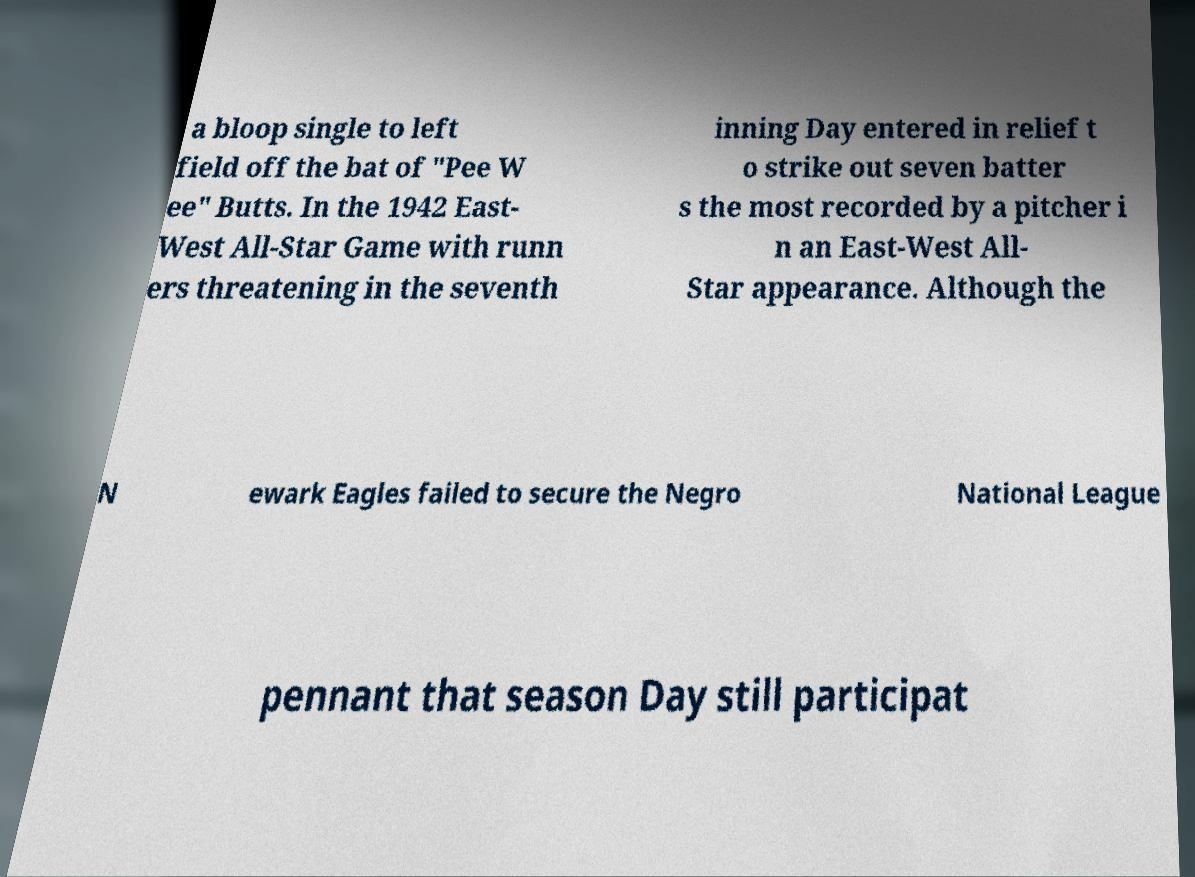Please read and relay the text visible in this image. What does it say? a bloop single to left field off the bat of "Pee W ee" Butts. In the 1942 East- West All-Star Game with runn ers threatening in the seventh inning Day entered in relief t o strike out seven batter s the most recorded by a pitcher i n an East-West All- Star appearance. Although the N ewark Eagles failed to secure the Negro National League pennant that season Day still participat 